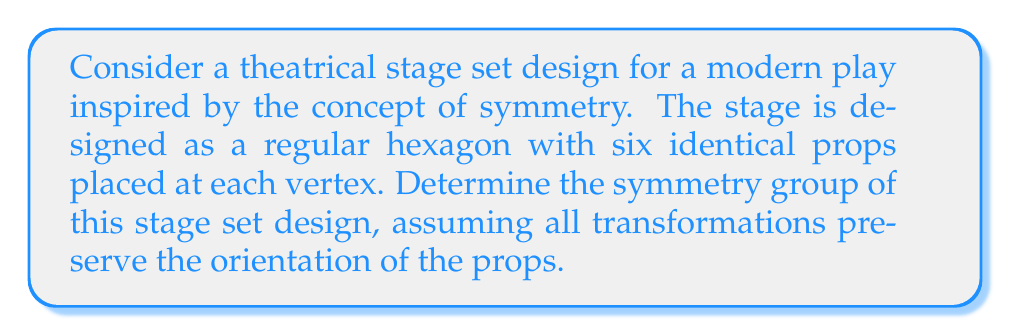What is the answer to this math problem? To determine the symmetry group of this stage set design, we'll follow these steps:

1) Identify the possible symmetries:
   - Rotational symmetries
   - Reflection symmetries

2) Rotational symmetries:
   - The stage can be rotated by multiples of 60° (360°/6) and maintain its appearance.
   - There are 6 rotational symmetries: 0°, 60°, 120°, 180°, 240°, 300°

3) Reflection symmetries:
   - There are 6 lines of reflection passing through each vertex and the center of the opposite side.

4) Total number of symmetries:
   - 6 rotations + 6 reflections = 12 symmetries

5) Identify the group:
   - This group of 12 symmetries is isomorphic to the dihedral group $D_6$.
   - $D_6$ is the symmetry group of a regular hexagon.

6) Group structure:
   - $D_6$ is generated by two elements: a rotation $r$ by 60° and a reflection $s$.
   - The group can be presented as: $D_6 = \langle r,s | r^6 = s^2 = 1, srs = r^{-1} \rangle$

7) Group elements:
   $$D_6 = \{1, r, r^2, r^3, r^4, r^5, s, sr, sr^2, sr^3, sr^4, sr^5\}$$

8) Artistic interpretation:
   - This symmetry group reflects the balance and harmony in the stage design, mirroring themes of repetition and transformation often found in modern plays.
Answer: $D_6$ 